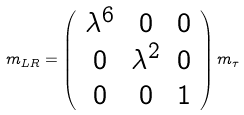Convert formula to latex. <formula><loc_0><loc_0><loc_500><loc_500>m _ { L R } = \left ( \begin{array} { c c c } \lambda ^ { 6 } & 0 & 0 \\ 0 & \lambda ^ { 2 } & 0 \\ 0 & 0 & 1 \end{array} \right ) m _ { \tau }</formula> 